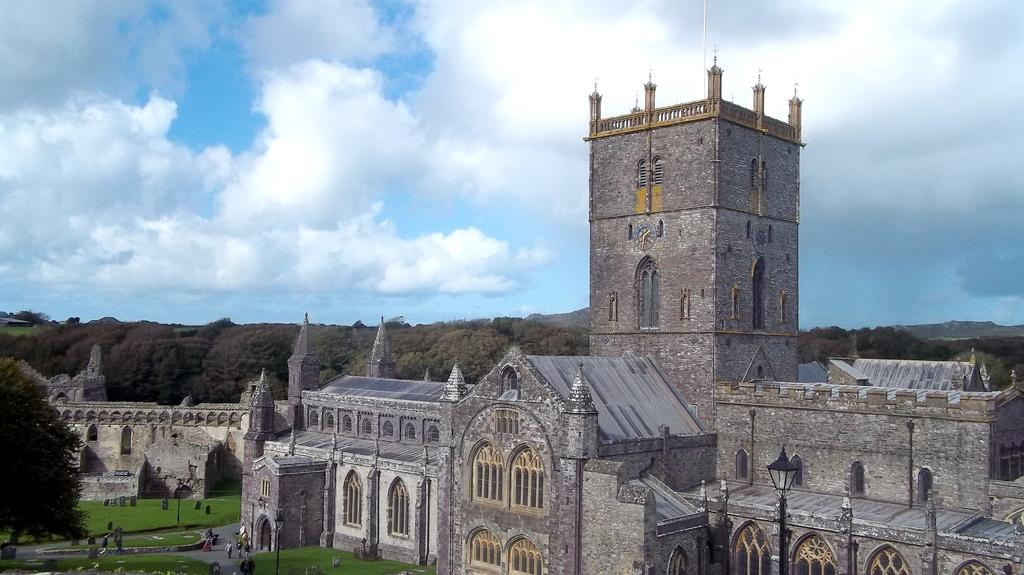What is the main structure in the center of the image? There is a stone castle in the center of the image. Are there any living beings in the image? Yes, there are people in the image. What type of objects can be seen in the image? There are tombstones in the image. What is the natural environment like in the image? There is grassland in the image, and trees can be seen in the background. What is visible in the sky in the image? The sky is visible in the background of the image. How many apples are being held by the goose in the image? There is no goose present in the image, and therefore no apples can be held by a goose. 